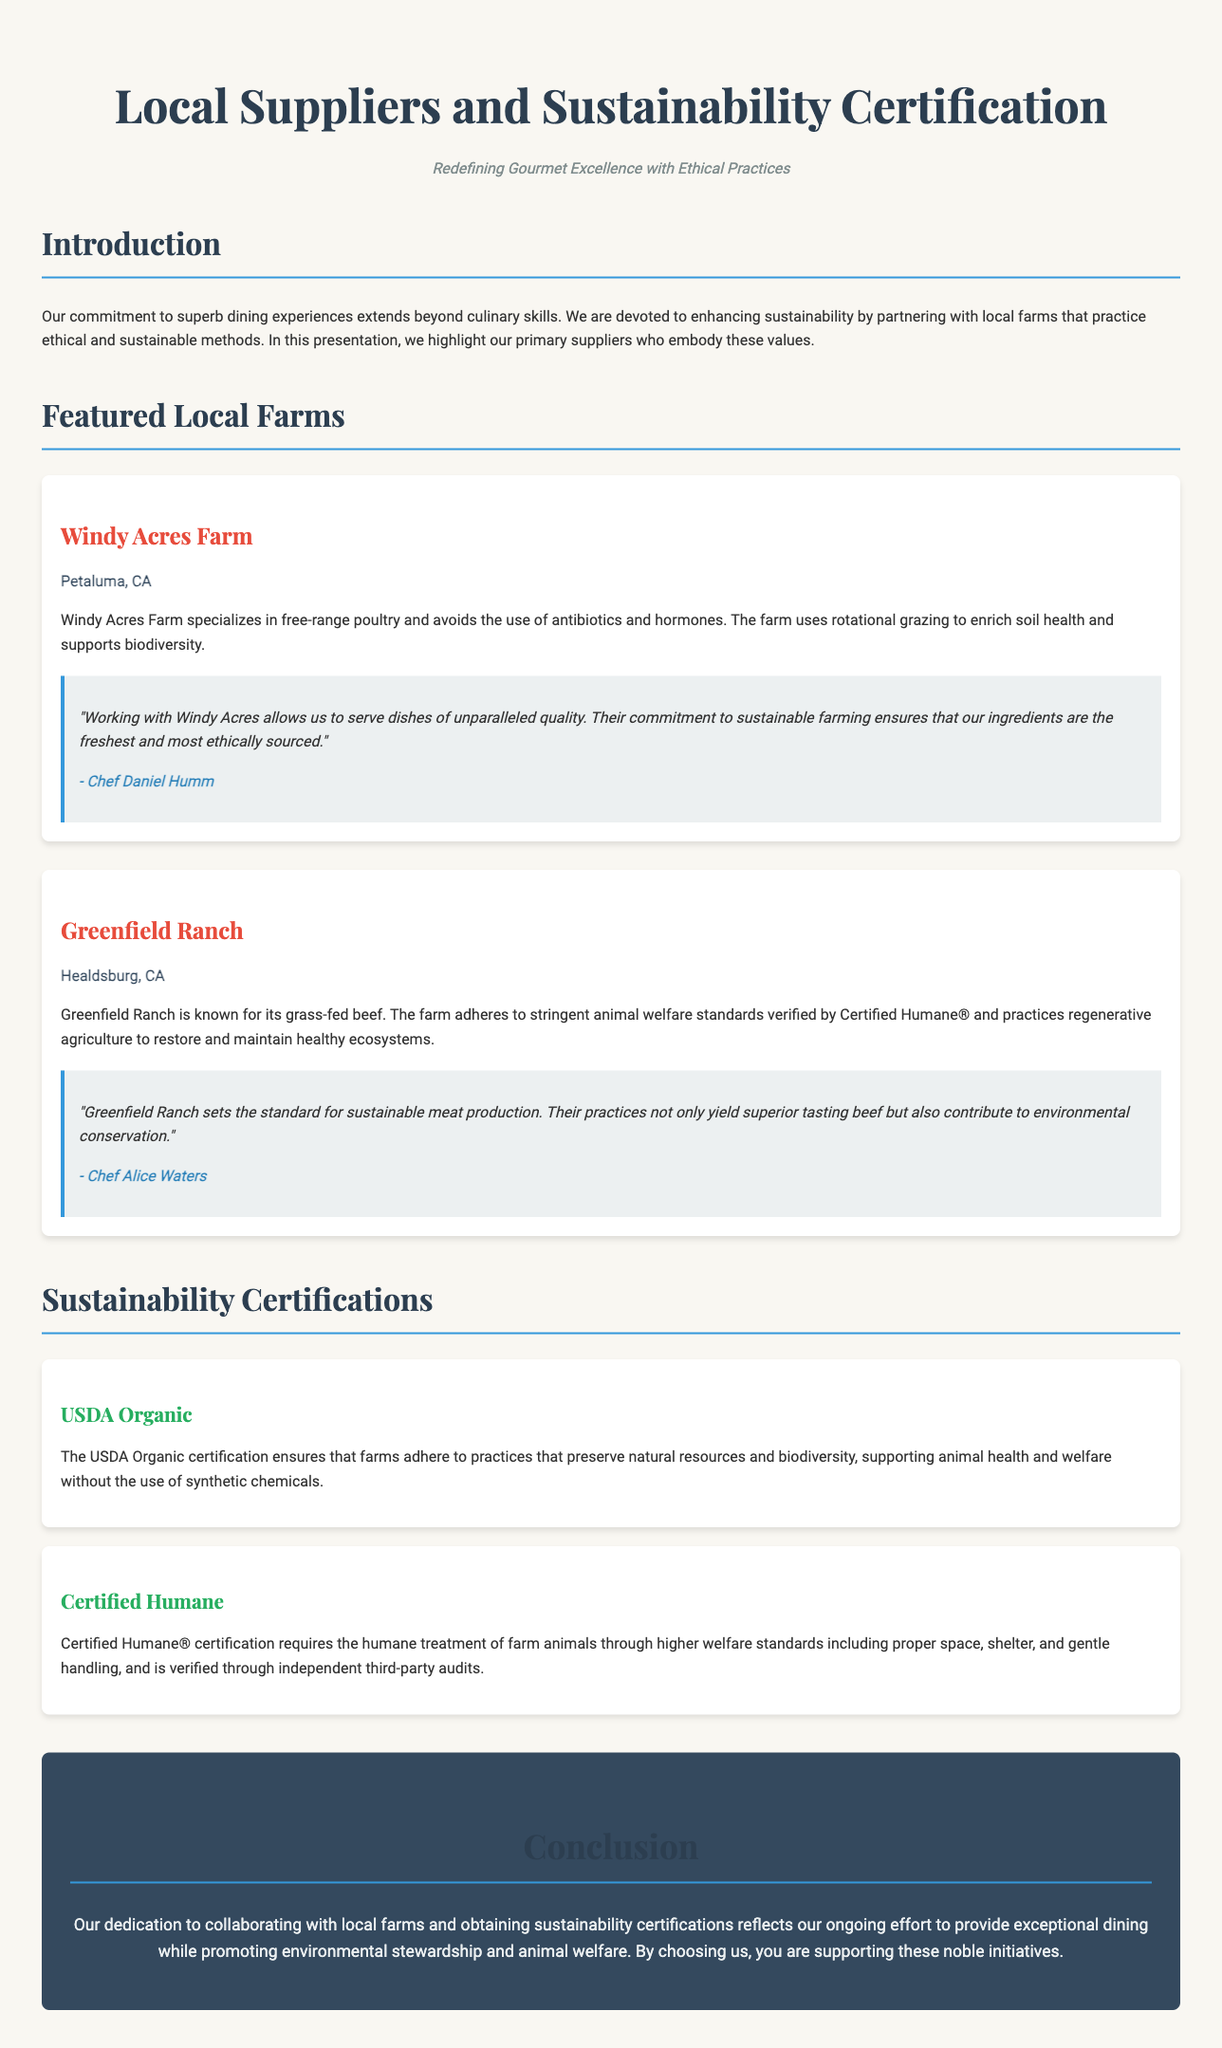what is the title of the document? The title is found in the `<title>` tag of the HTML document, which states the main topic of the presentation.
Answer: Local Suppliers and Sustainability Certification what is the name of the first featured farm? The name of the first farm is presented in the first farm card's title.
Answer: Windy Acres Farm what type of farming method is used at Windy Acres Farm? The document mentions the farming method used at Windy Acres, emphasizing its approach to poultry production.
Answer: Free-range poultry what certification ensures humane treatment of farm animals? The document explicitly states the certification related to animal welfare, highlighting its implications for breeding practices.
Answer: Certified Humane who is the author of the testimonial for Greenfield Ranch? The author of the testimonial is highlighted in the quote under the Greenfield Ranch section, indicating their endorsement and perspective.
Answer: Chef Alice Waters what does USDA Organic certification support? The document summarizes the goals of USDA Organic certification in terms of agricultural practices and environmental health.
Answer: Natural resources and biodiversity which farm is located in Healdsburg, CA? The location of the farms is specified in their respective farm cards, aiding in geographical identification.
Answer: Greenfield Ranch how many sustainability certifications are listed in the document? The document contains a specific mention of the number of certifications that emphasize safety and ethical practices on farms.
Answer: 2 what is the color of the heading "Featured Local Farms"? The document styling specifies the color code used for the heading, which visually distinguishes the section.
Answer: Dark gray (or #2c3e50) what is the overarching theme of the document? The theme is articulated in the introduction, summarizing the document’s purpose and focus areas regarding local partnerships.
Answer: Sustainability and ethical practices 